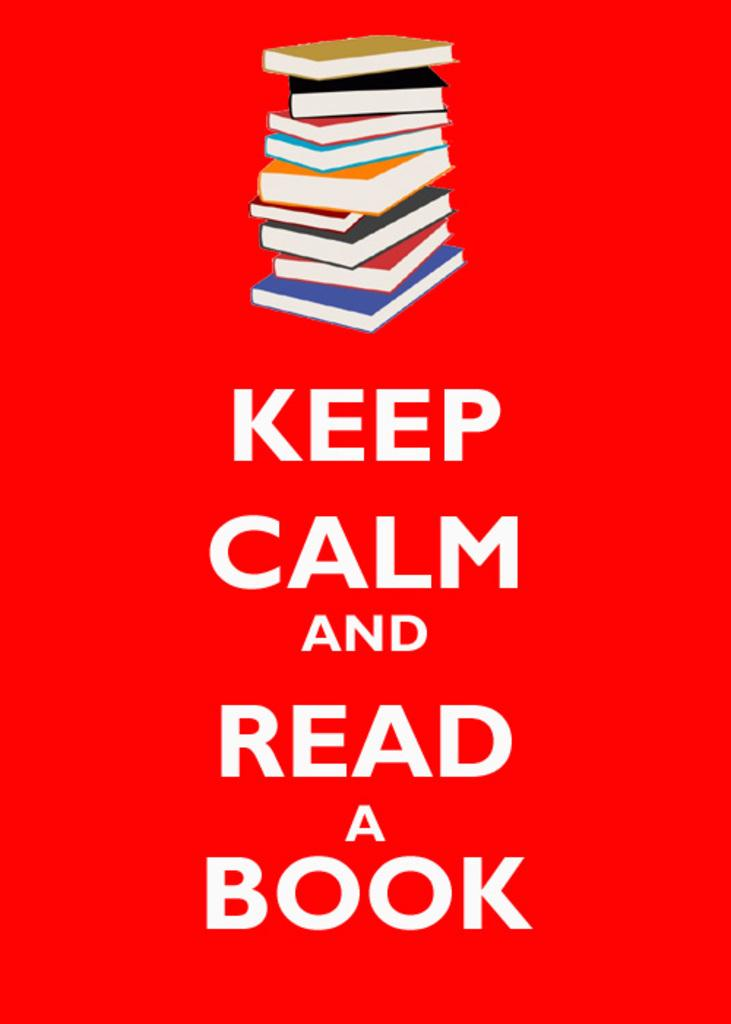<image>
Provide a brief description of the given image. A bright poster suggesting that one should read a book. 